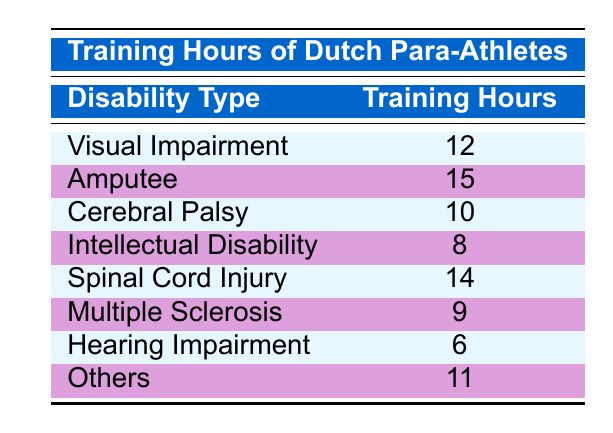What disability type has the highest training hours? The table shows that the "Amputee" disability type has the highest training hours at 15. By comparing the training hours listed for each disability type, it is clear that 15 is the maximum value present.
Answer: Amputee How many training hours do para-athletes with Visual Impairment train? According to the table, para-athletes with Visual Impairment train for 12 hours. This value is directly stated in the corresponding row.
Answer: 12 What is the total number of training hours for para-athletes with Spinal Cord Injury and Multiple Sclerosis? To find the total training hours for both disability types, I add the training hours for "Spinal Cord Injury" (14) and "Multiple Sclerosis" (9). The sum is 14 + 9 = 23.
Answer: 23 Is the average training hours for para-athletes with Intellectual Disability higher than 10? The training hours for Intellectual Disability is 8. Since 8 is less than 10, the statement is false. After consulting the table, it is confirmed that the hour value is definitely lower than 10.
Answer: No Which disability type has training hours less than 10? Looking at the table, both "Intellectual Disability" (8) and "Hearing Impairment" (6) have training hours that are less than 10. They are individually examined and confirmed to be below this threshold.
Answer: Intellectual Disability, Hearing Impairment What is the difference in training hours between the disability type with the highest and the lowest training hours? The highest training hours are for "Amputee" (15) and the lowest for "Hearing Impairment" (6). The difference is calculated as 15 - 6 = 9.
Answer: 9 How many disability types have more than 12 training hours? The table indicates that "Amputee" (15) and "Spinal Cord Injury" (14) both have training hours exceeding 12. Therefore, there are 2 disability types that meet this criterion, which can be verified by counting them.
Answer: 2 What are the training hours for athletes with disabilities other than Hearing Impairment? Summing the training hours for the remaining disability types—Visual Impairment (12), Amputee (15), Cerebral Palsy (10), Intellectual Disability (8), Spinal Cord Injury (14), Multiple Sclerosis (9), and Others (11), we get 12 + 15 + 10 + 8 + 14 + 9 + 11 = 89 hours. Hence, the total training hours for all other disability types is 89.
Answer: 89 